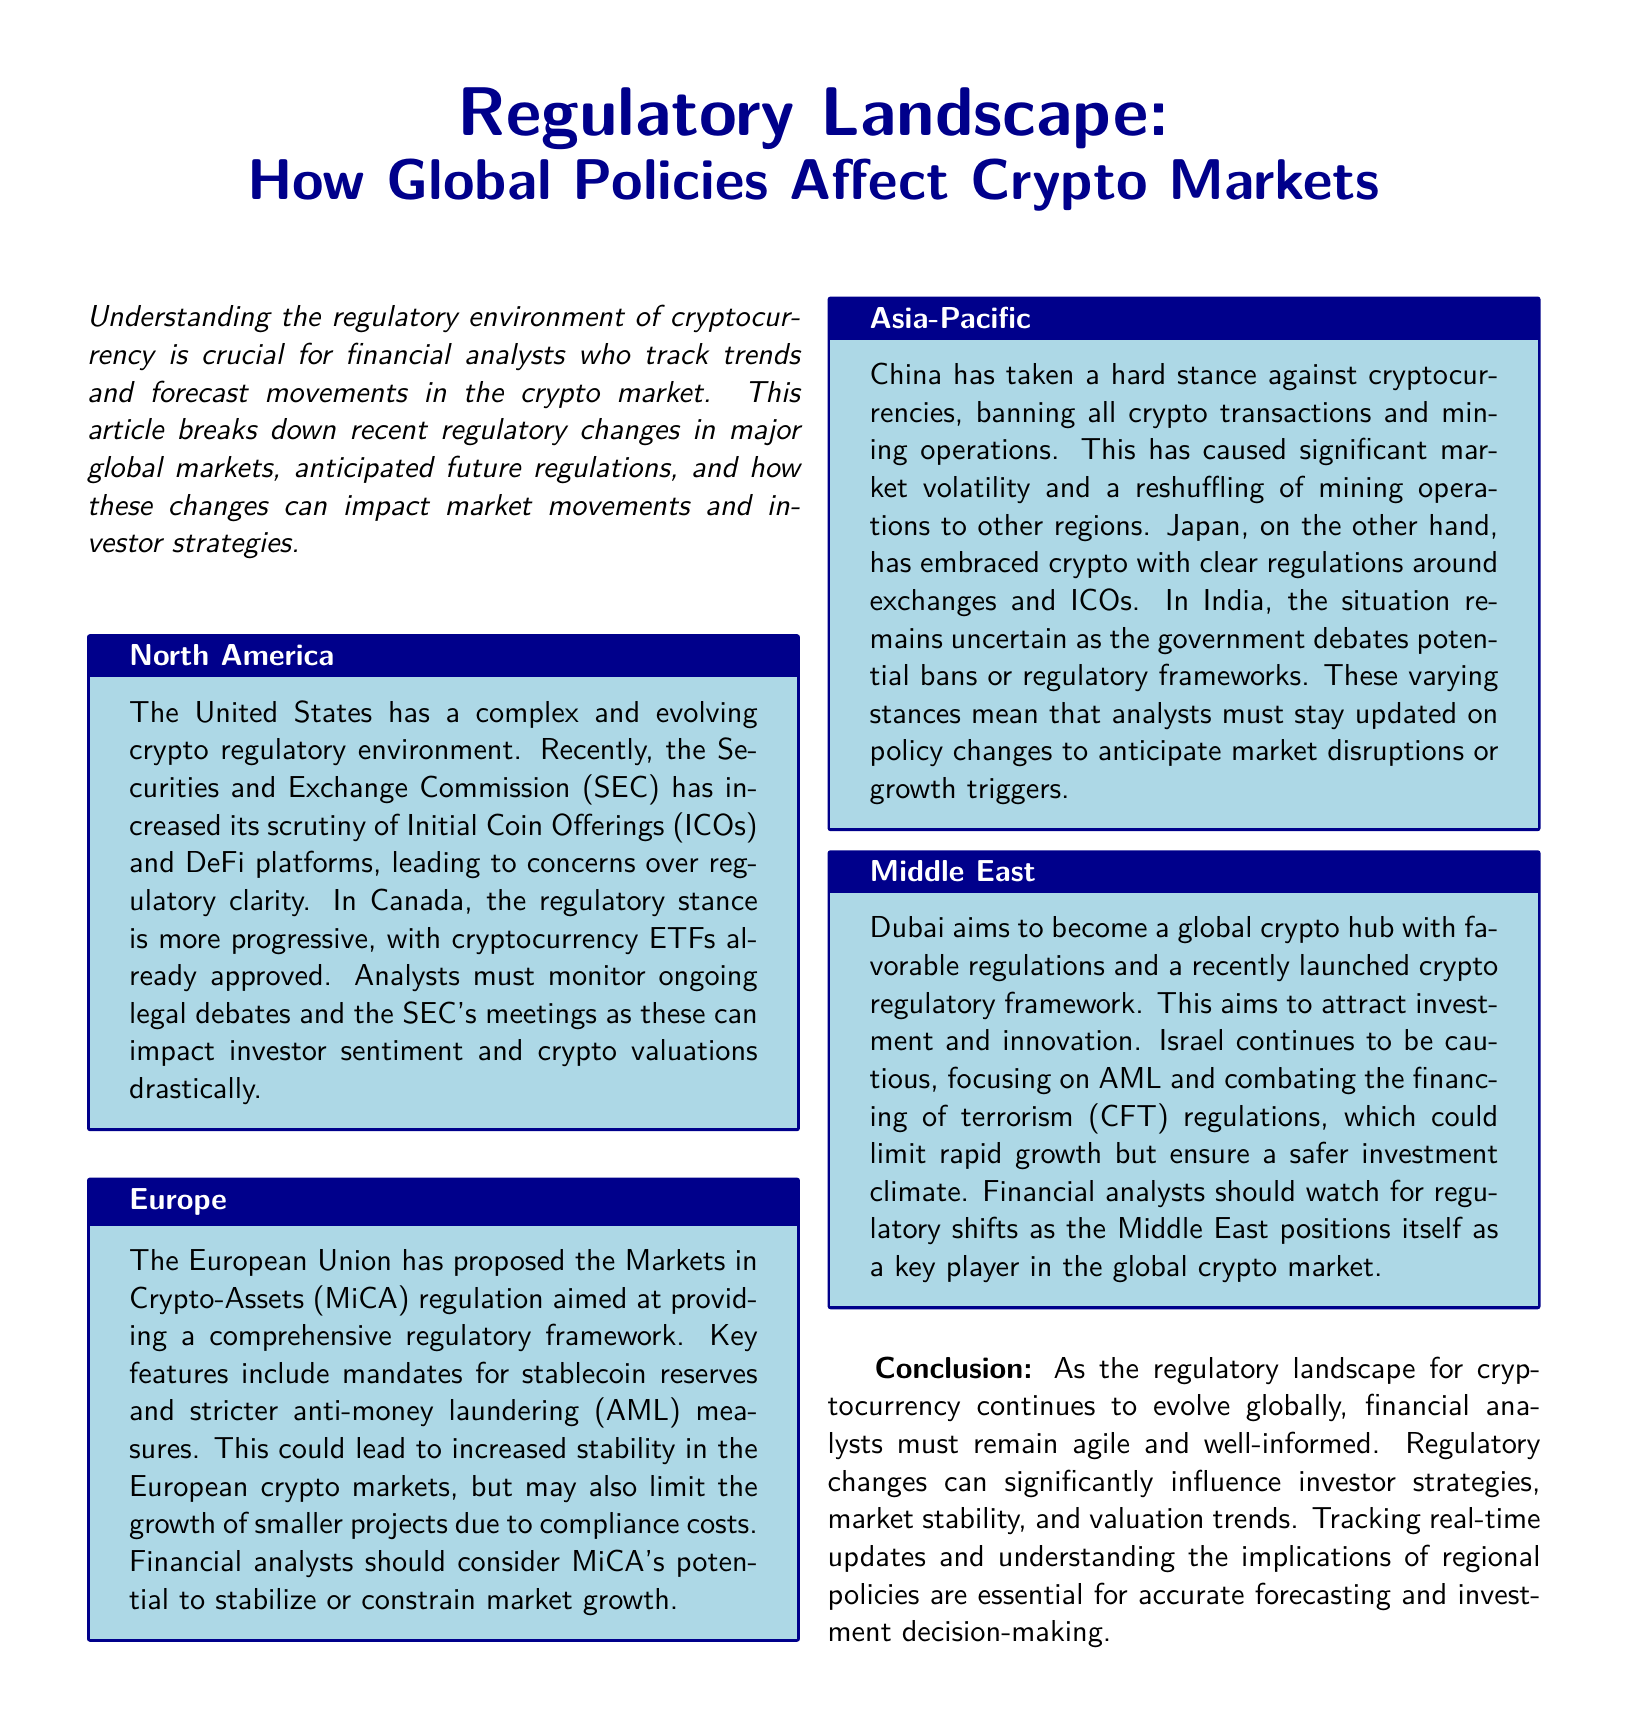What recent regulation has the SEC increased its scrutiny on? The SEC has increased its scrutiny on Initial Coin Offerings (ICOs) and DeFi platforms in the US.
Answer: Initial Coin Offerings (ICOs) What regulatory framework has the European Union proposed? The European Union has proposed the Markets in Crypto-Assets (MiCA) regulation.
Answer: MiCA Which country has banned all crypto transactions? China has taken a hard stance against cryptocurrencies, banning all crypto transactions.
Answer: China What is Dubai's aim concerning the crypto market? Dubai aims to become a global crypto hub with favorable regulations.
Answer: Global crypto hub What is a potential effect of MiCA regulation mentioned in the article? MiCA's potential effect includes increased stability in the European crypto markets.
Answer: Increased stability Which country remains uncertain regarding its crypto regulations? India’s regulatory situation remains uncertain as the government debates potential bans or frameworks.
Answer: India What must analysts monitor closely in North America? Analysts must monitor ongoing legal debates and the SEC's meetings.
Answer: Ongoing legal debates What key area do Israel's regulations focus on? Israel's regulations focus on anti-money laundering (AML) and combating the financing of terrorism (CFT).
Answer: AML and CFT How does the regulatory stance in Canada differ from that in the US? Canada has a more progressive regulatory stance, having already approved cryptocurrency ETFs.
Answer: More progressive 